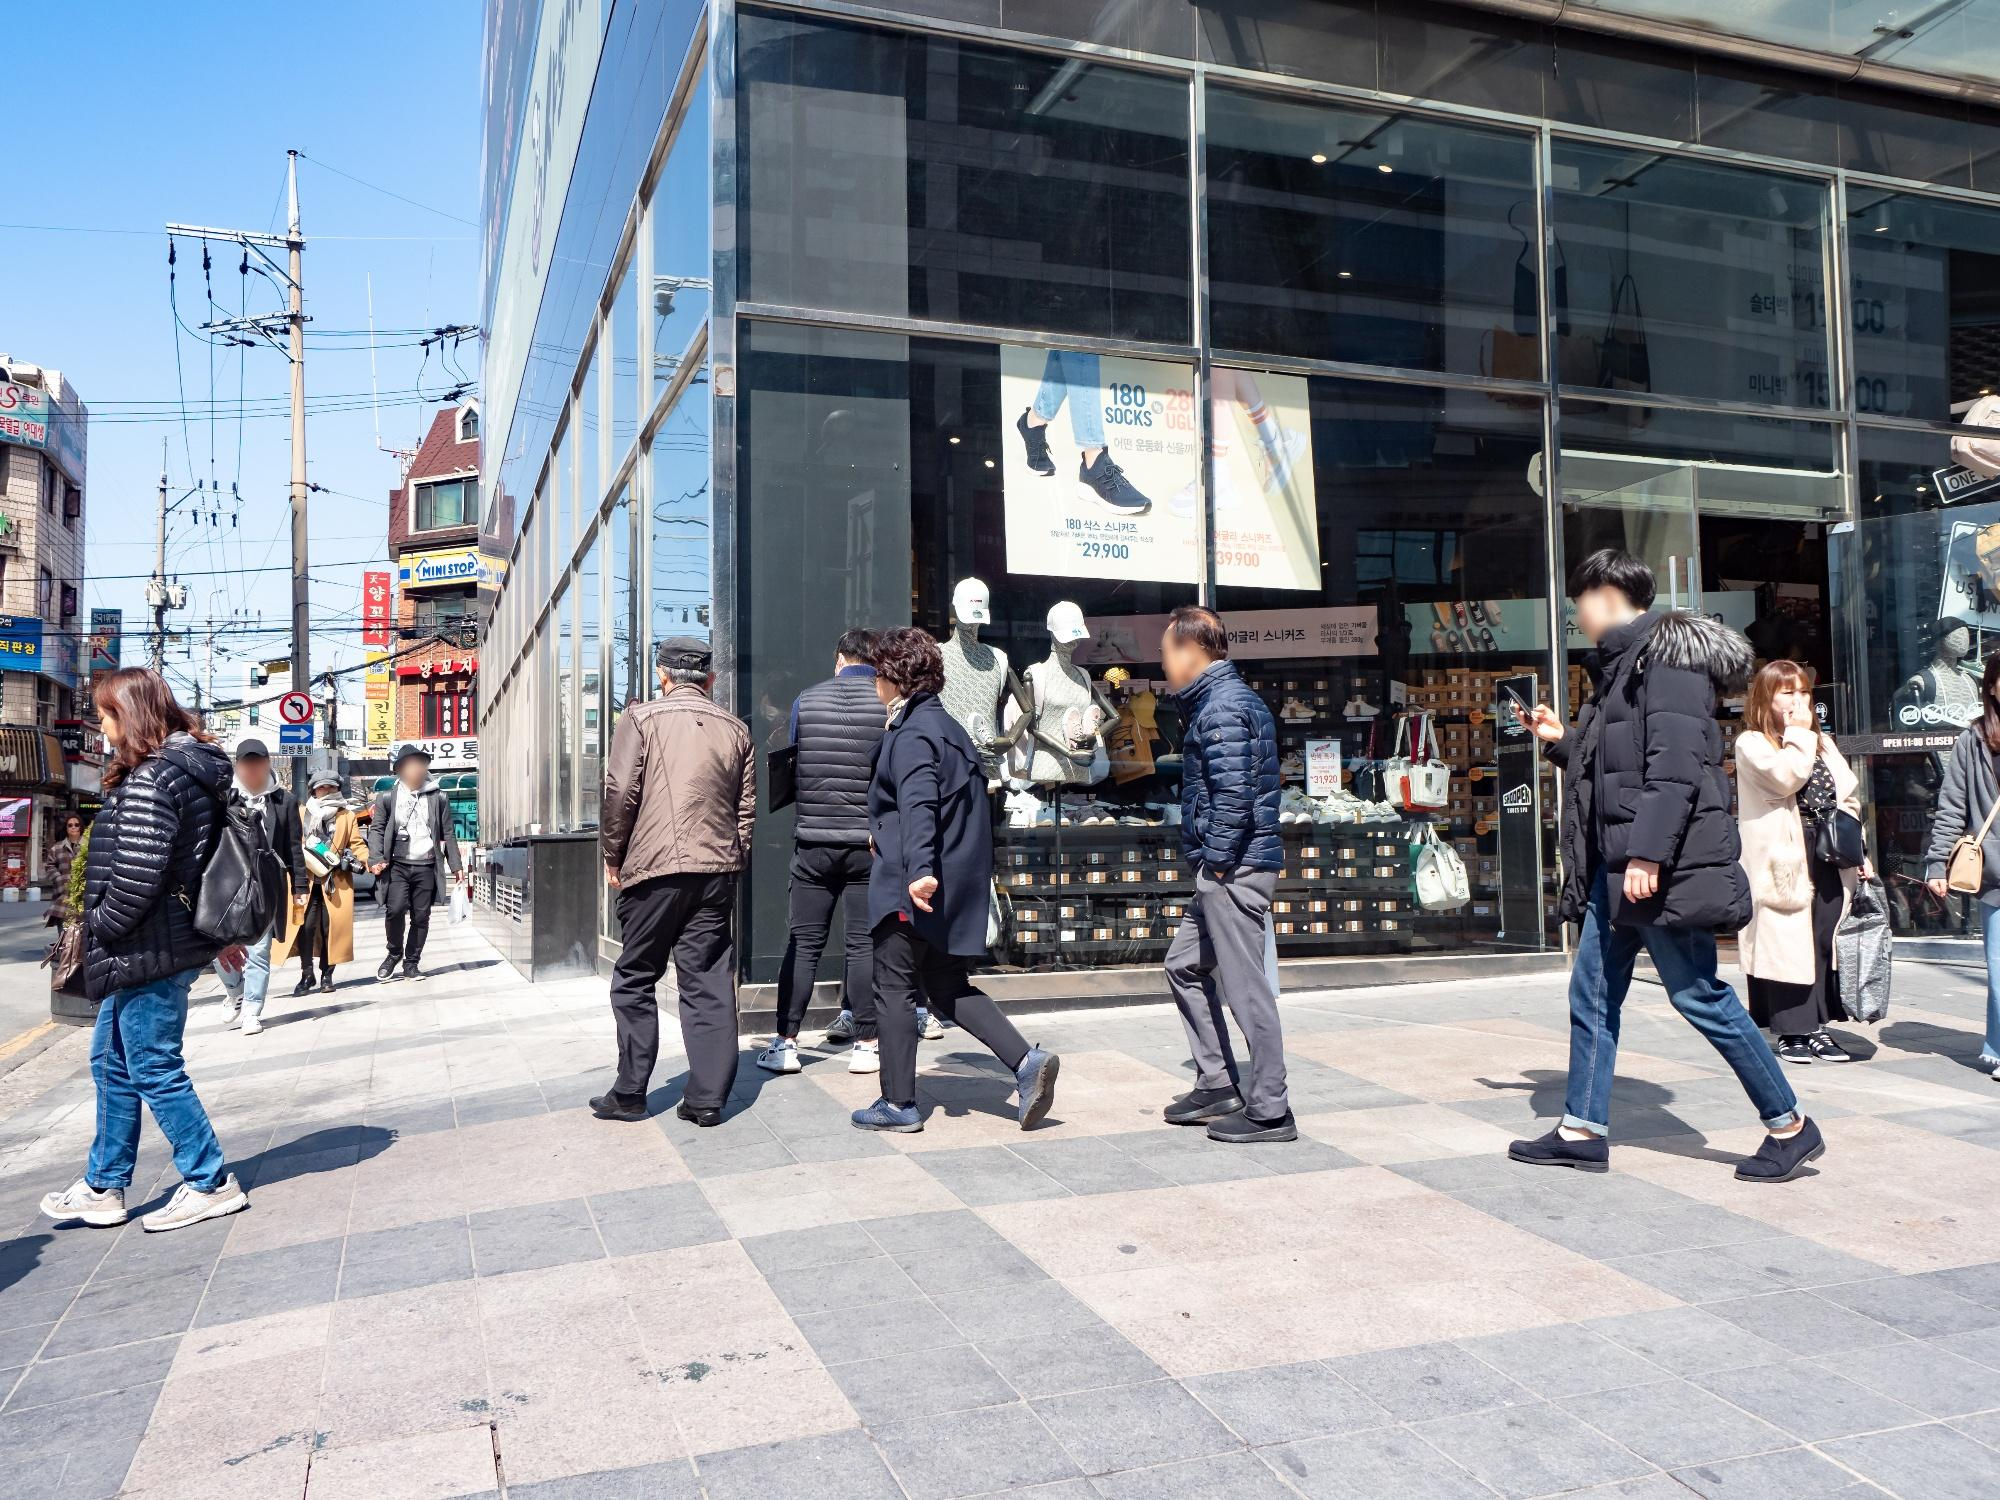Can you tell more about the types of shops visible on this street? Certainly! The street islined with a diverse array of shops. On the right, there's a large store prominently advertising socks, with banners showing varying styles and prices which indicates a specialized shop for fashionable accessories. Other visible signs suggest the presence of clothing stores, possibly a restaurant or café due to the presence of banners that could indicate menu items or specials. These varieties suggest that this street is a popular destination for both regular needs and leisure shopping, possibly attracting a wide range of shoppers. 